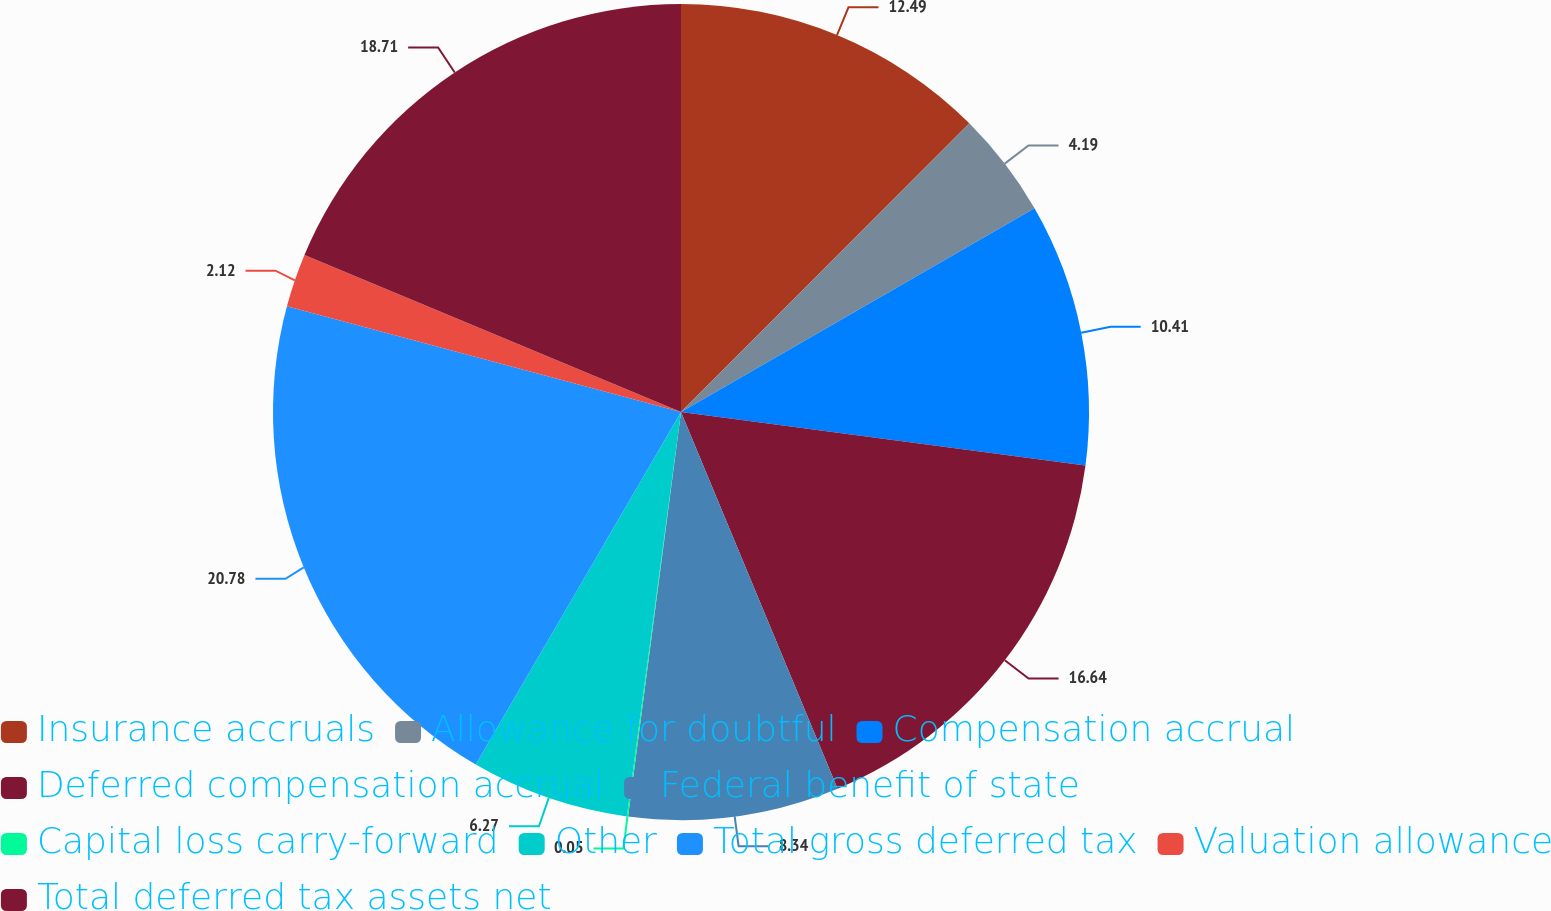Convert chart. <chart><loc_0><loc_0><loc_500><loc_500><pie_chart><fcel>Insurance accruals<fcel>Allowance for doubtful<fcel>Compensation accrual<fcel>Deferred compensation accrual<fcel>Federal benefit of state<fcel>Capital loss carry-forward<fcel>Other<fcel>Total gross deferred tax<fcel>Valuation allowance<fcel>Total deferred tax assets net<nl><fcel>12.49%<fcel>4.19%<fcel>10.41%<fcel>16.64%<fcel>8.34%<fcel>0.05%<fcel>6.27%<fcel>20.78%<fcel>2.12%<fcel>18.71%<nl></chart> 